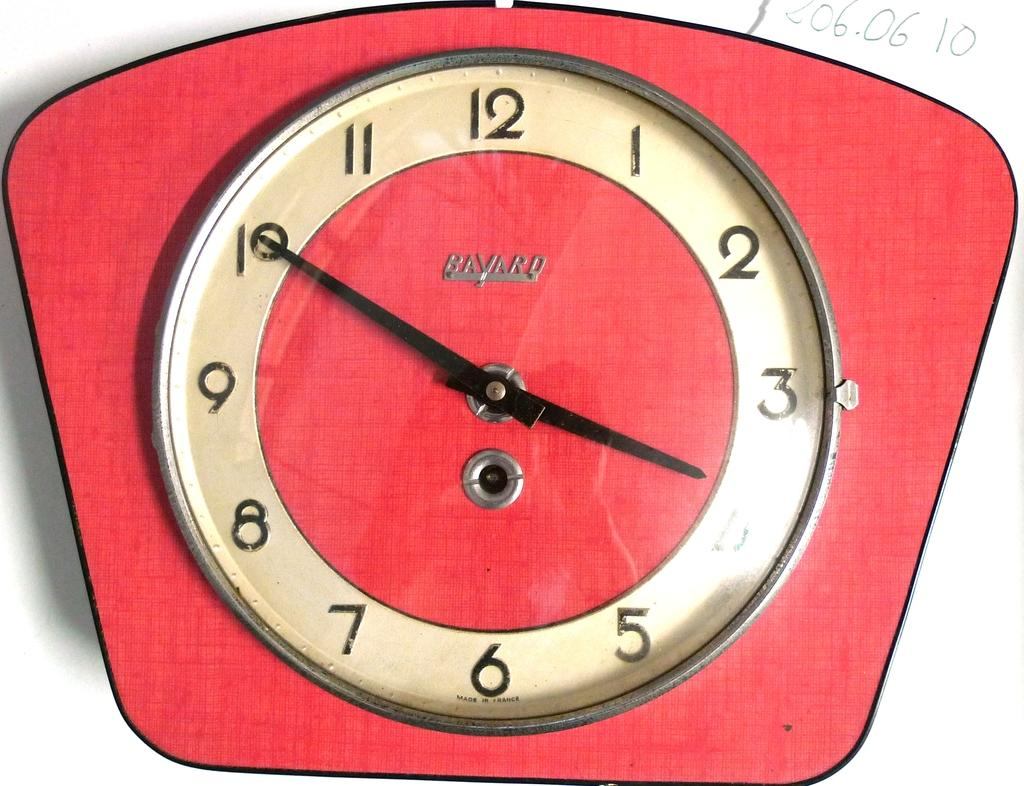<image>
Create a compact narrative representing the image presented. A clock has a Bavard logo on the front. 